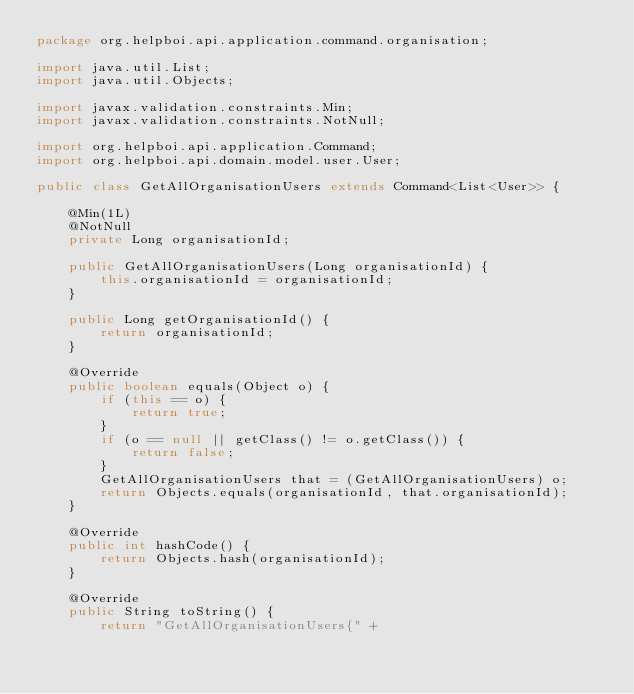<code> <loc_0><loc_0><loc_500><loc_500><_Java_>package org.helpboi.api.application.command.organisation;

import java.util.List;
import java.util.Objects;

import javax.validation.constraints.Min;
import javax.validation.constraints.NotNull;

import org.helpboi.api.application.Command;
import org.helpboi.api.domain.model.user.User;

public class GetAllOrganisationUsers extends Command<List<User>> {

    @Min(1L)
    @NotNull
    private Long organisationId;

    public GetAllOrganisationUsers(Long organisationId) {
        this.organisationId = organisationId;
    }

    public Long getOrganisationId() {
        return organisationId;
    }

    @Override
    public boolean equals(Object o) {
        if (this == o) {
            return true;
        }
        if (o == null || getClass() != o.getClass()) {
            return false;
        }
        GetAllOrganisationUsers that = (GetAllOrganisationUsers) o;
        return Objects.equals(organisationId, that.organisationId);
    }

    @Override
    public int hashCode() {
        return Objects.hash(organisationId);
    }

    @Override
    public String toString() {
        return "GetAllOrganisationUsers{" +</code> 